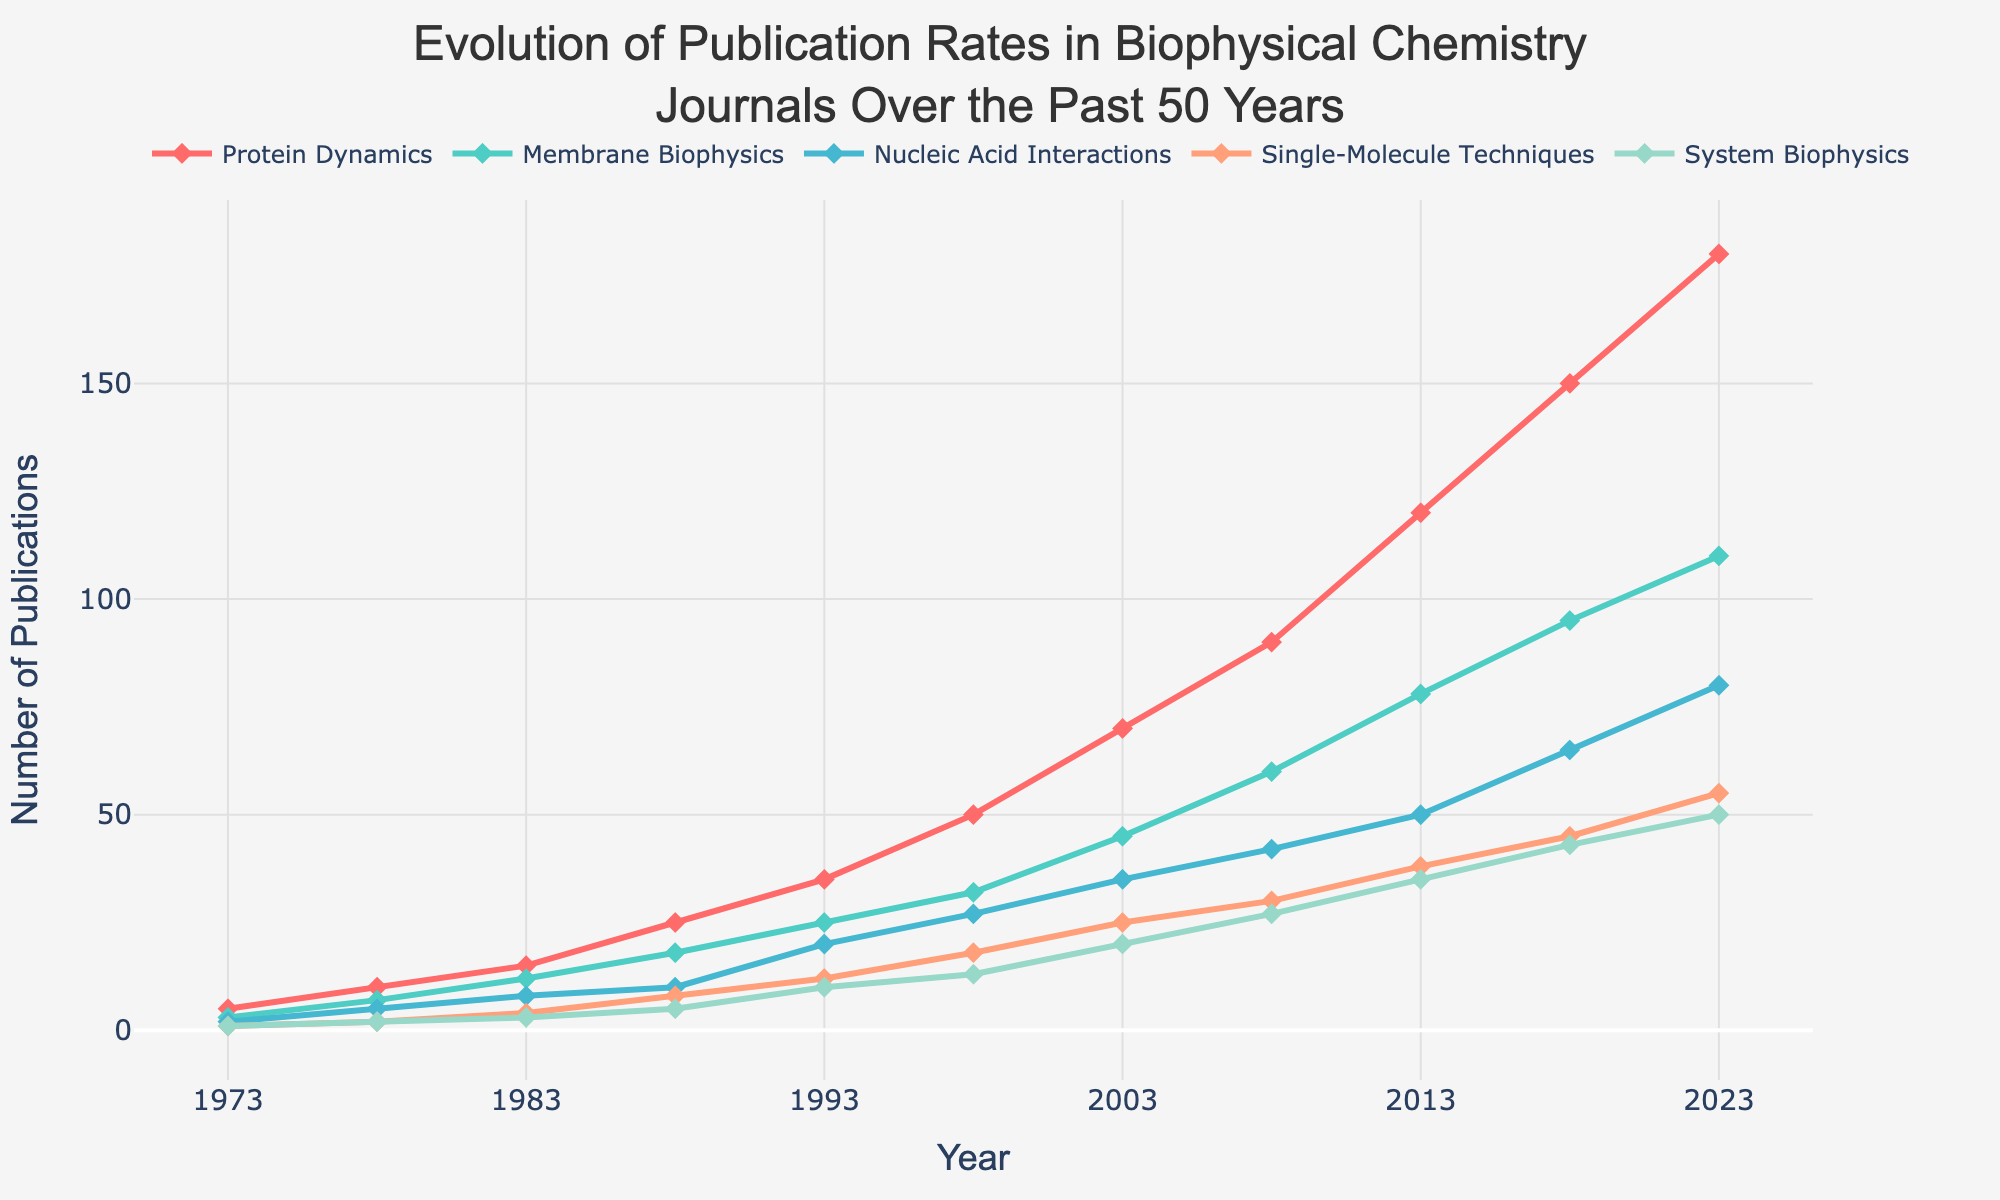What's the title of the figure? The title is displayed at the top of the figure and reads, "Evolution of Publication Rates in Biophysical Chemistry Journals Over the Past 50 Years".
Answer: Evolution of Publication Rates in Biophysical Chemistry Journals Over the Past 50 Years What years are shown on the x-axis? The x-axis displays the years, ranging from 1973 to 2023.
Answer: 1973 to 2023 Which research focus had the highest number of publications in 2023? By looking at the endpoint of each line series at the year 2023, the research focus "Protein Dynamics" shows the highest number of publications.
Answer: Protein Dynamics Between which years did "Membrane Biophysics" show the most significant increase in publication rate? Observing the "Membrane Biophysics" line, the steepest slope appears between 1973 and 1983. This indicates the most significant increase during that period.
Answer: 1973 - 1983 How many total publications were there across all research focuses in 1988? Adding the number of publications for each research focus in 1988: 25 (Protein Dynamics) + 18 (Membrane Biophysics) + 10 (Nucleic Acid Interactions) + 8 (Single-Molecule Techniques) + 5 (System Biophysics) = 66 publications.
Answer: 66 Which research focus had the least increase in publications from 1973 to 2023? Comparing the increase for each research focus: 
  - Protein Dynamics: 180 - 5 = 175
  - Membrane Biophysics: 110 - 3 = 107
  - Nucleic Acid Interactions: 80 - 2 = 78
  - Single-Molecule Techniques: 55 - 1 = 54
  - System Biophysics: 50 - 1 = 49
The "System Biophysics" focus had the smallest increase.
Answer: System Biophysics During which decade did "Single-Molecule Techniques" see a growth from fewer than 10 to more than 20 publications? Observing the line for "Single-Molecule Techniques", it crossed the 10 publications mark between 1983 (4) and 1988 (8), and then crossed the 20 publications mark in the following decade, around 1993 (12) and onwards.
Answer: 1983 to 1993 In what year did the publication rate of "Nucleic Acid Interactions" exceed 50 publications? Referring to the "Nucleic Acid Interactions" line, it exceeded 50 publications around the year 2013.
Answer: 2013 Which two research focuses had the closest publication rates in 2008? By comparing the y-values for each research focus in 2008, "Single-Molecule Techniques" (30) and "System Biophysics" (27) had closely aligned rates.
Answer: Single-Molecule Techniques and System Biophysics 